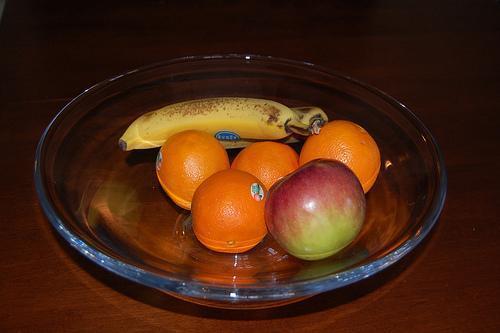How many different types of fruits are shown?
Give a very brief answer. 3. 